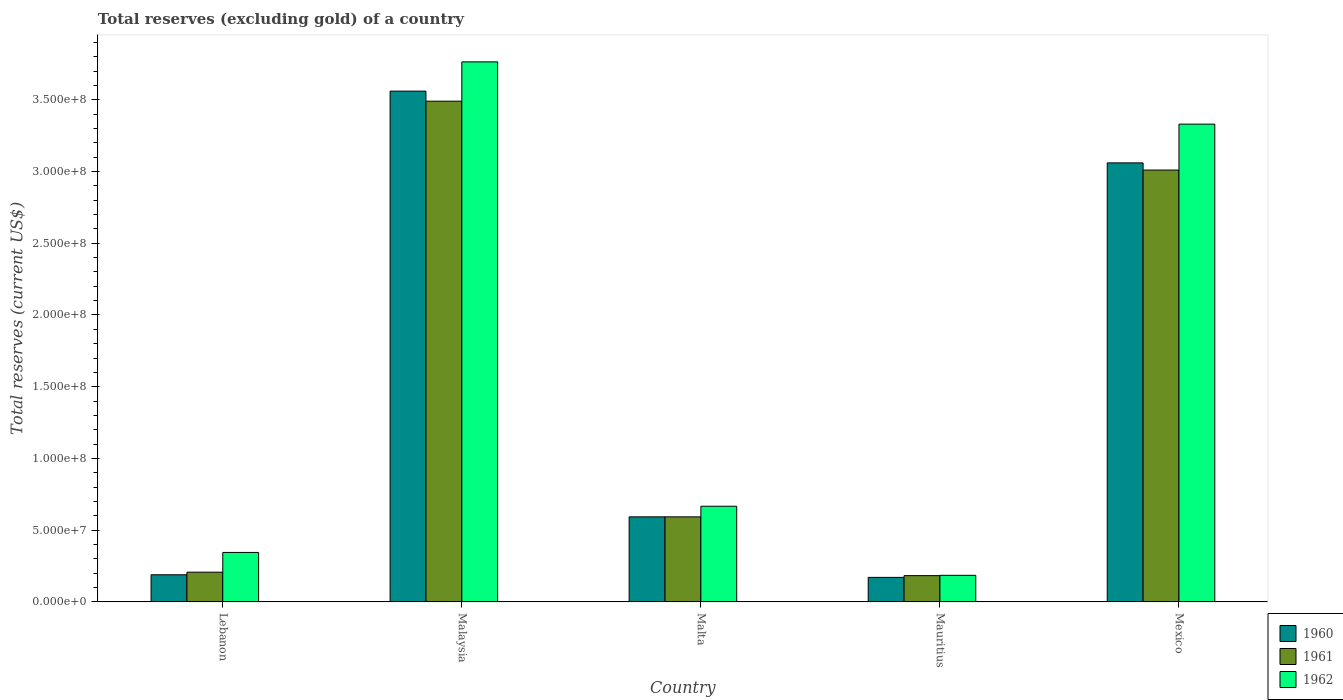Are the number of bars per tick equal to the number of legend labels?
Ensure brevity in your answer.  Yes. How many bars are there on the 1st tick from the left?
Ensure brevity in your answer.  3. How many bars are there on the 5th tick from the right?
Your response must be concise. 3. What is the label of the 3rd group of bars from the left?
Your response must be concise. Malta. In how many cases, is the number of bars for a given country not equal to the number of legend labels?
Provide a succinct answer. 0. What is the total reserves (excluding gold) in 1961 in Malta?
Your answer should be very brief. 5.93e+07. Across all countries, what is the maximum total reserves (excluding gold) in 1960?
Offer a terse response. 3.56e+08. Across all countries, what is the minimum total reserves (excluding gold) in 1960?
Offer a terse response. 1.71e+07. In which country was the total reserves (excluding gold) in 1962 maximum?
Your response must be concise. Malaysia. In which country was the total reserves (excluding gold) in 1960 minimum?
Provide a short and direct response. Mauritius. What is the total total reserves (excluding gold) in 1961 in the graph?
Provide a short and direct response. 7.48e+08. What is the difference between the total reserves (excluding gold) in 1960 in Malaysia and that in Malta?
Your response must be concise. 2.97e+08. What is the difference between the total reserves (excluding gold) in 1960 in Malta and the total reserves (excluding gold) in 1962 in Lebanon?
Your response must be concise. 2.48e+07. What is the average total reserves (excluding gold) in 1960 per country?
Keep it short and to the point. 1.51e+08. What is the difference between the total reserves (excluding gold) of/in 1960 and total reserves (excluding gold) of/in 1962 in Malta?
Offer a terse response. -7.40e+06. What is the ratio of the total reserves (excluding gold) in 1962 in Lebanon to that in Malaysia?
Offer a very short reply. 0.09. Is the total reserves (excluding gold) in 1962 in Malta less than that in Mauritius?
Provide a succinct answer. No. What is the difference between the highest and the second highest total reserves (excluding gold) in 1960?
Provide a short and direct response. 2.97e+08. What is the difference between the highest and the lowest total reserves (excluding gold) in 1962?
Ensure brevity in your answer.  3.58e+08. In how many countries, is the total reserves (excluding gold) in 1962 greater than the average total reserves (excluding gold) in 1962 taken over all countries?
Give a very brief answer. 2. What does the 2nd bar from the right in Malta represents?
Offer a terse response. 1961. Are all the bars in the graph horizontal?
Your answer should be very brief. No. Are the values on the major ticks of Y-axis written in scientific E-notation?
Your answer should be very brief. Yes. Does the graph contain any zero values?
Give a very brief answer. No. Does the graph contain grids?
Ensure brevity in your answer.  No. Where does the legend appear in the graph?
Provide a succinct answer. Bottom right. What is the title of the graph?
Provide a succinct answer. Total reserves (excluding gold) of a country. What is the label or title of the X-axis?
Provide a short and direct response. Country. What is the label or title of the Y-axis?
Offer a very short reply. Total reserves (current US$). What is the Total reserves (current US$) of 1960 in Lebanon?
Keep it short and to the point. 1.89e+07. What is the Total reserves (current US$) of 1961 in Lebanon?
Offer a terse response. 2.07e+07. What is the Total reserves (current US$) in 1962 in Lebanon?
Ensure brevity in your answer.  3.45e+07. What is the Total reserves (current US$) in 1960 in Malaysia?
Provide a succinct answer. 3.56e+08. What is the Total reserves (current US$) of 1961 in Malaysia?
Offer a terse response. 3.49e+08. What is the Total reserves (current US$) in 1962 in Malaysia?
Your answer should be compact. 3.76e+08. What is the Total reserves (current US$) of 1960 in Malta?
Offer a very short reply. 5.93e+07. What is the Total reserves (current US$) in 1961 in Malta?
Provide a short and direct response. 5.93e+07. What is the Total reserves (current US$) of 1962 in Malta?
Provide a short and direct response. 6.67e+07. What is the Total reserves (current US$) in 1960 in Mauritius?
Provide a short and direct response. 1.71e+07. What is the Total reserves (current US$) in 1961 in Mauritius?
Your answer should be compact. 1.83e+07. What is the Total reserves (current US$) of 1962 in Mauritius?
Provide a succinct answer. 1.86e+07. What is the Total reserves (current US$) in 1960 in Mexico?
Keep it short and to the point. 3.06e+08. What is the Total reserves (current US$) in 1961 in Mexico?
Offer a very short reply. 3.01e+08. What is the Total reserves (current US$) of 1962 in Mexico?
Offer a very short reply. 3.33e+08. Across all countries, what is the maximum Total reserves (current US$) of 1960?
Provide a succinct answer. 3.56e+08. Across all countries, what is the maximum Total reserves (current US$) of 1961?
Provide a succinct answer. 3.49e+08. Across all countries, what is the maximum Total reserves (current US$) of 1962?
Make the answer very short. 3.76e+08. Across all countries, what is the minimum Total reserves (current US$) of 1960?
Provide a succinct answer. 1.71e+07. Across all countries, what is the minimum Total reserves (current US$) of 1961?
Give a very brief answer. 1.83e+07. Across all countries, what is the minimum Total reserves (current US$) of 1962?
Offer a terse response. 1.86e+07. What is the total Total reserves (current US$) of 1960 in the graph?
Offer a terse response. 7.57e+08. What is the total Total reserves (current US$) in 1961 in the graph?
Your response must be concise. 7.48e+08. What is the total Total reserves (current US$) of 1962 in the graph?
Your answer should be compact. 8.29e+08. What is the difference between the Total reserves (current US$) in 1960 in Lebanon and that in Malaysia?
Ensure brevity in your answer.  -3.37e+08. What is the difference between the Total reserves (current US$) in 1961 in Lebanon and that in Malaysia?
Give a very brief answer. -3.28e+08. What is the difference between the Total reserves (current US$) of 1962 in Lebanon and that in Malaysia?
Your answer should be compact. -3.42e+08. What is the difference between the Total reserves (current US$) of 1960 in Lebanon and that in Malta?
Offer a terse response. -4.04e+07. What is the difference between the Total reserves (current US$) of 1961 in Lebanon and that in Malta?
Your answer should be very brief. -3.86e+07. What is the difference between the Total reserves (current US$) of 1962 in Lebanon and that in Malta?
Your answer should be compact. -3.22e+07. What is the difference between the Total reserves (current US$) of 1960 in Lebanon and that in Mauritius?
Provide a succinct answer. 1.82e+06. What is the difference between the Total reserves (current US$) of 1961 in Lebanon and that in Mauritius?
Keep it short and to the point. 2.40e+06. What is the difference between the Total reserves (current US$) in 1962 in Lebanon and that in Mauritius?
Provide a succinct answer. 1.60e+07. What is the difference between the Total reserves (current US$) in 1960 in Lebanon and that in Mexico?
Make the answer very short. -2.87e+08. What is the difference between the Total reserves (current US$) in 1961 in Lebanon and that in Mexico?
Your answer should be very brief. -2.80e+08. What is the difference between the Total reserves (current US$) in 1962 in Lebanon and that in Mexico?
Give a very brief answer. -2.98e+08. What is the difference between the Total reserves (current US$) of 1960 in Malaysia and that in Malta?
Your answer should be very brief. 2.97e+08. What is the difference between the Total reserves (current US$) of 1961 in Malaysia and that in Malta?
Your answer should be compact. 2.90e+08. What is the difference between the Total reserves (current US$) of 1962 in Malaysia and that in Malta?
Keep it short and to the point. 3.10e+08. What is the difference between the Total reserves (current US$) in 1960 in Malaysia and that in Mauritius?
Offer a very short reply. 3.39e+08. What is the difference between the Total reserves (current US$) of 1961 in Malaysia and that in Mauritius?
Keep it short and to the point. 3.31e+08. What is the difference between the Total reserves (current US$) in 1962 in Malaysia and that in Mauritius?
Your answer should be very brief. 3.58e+08. What is the difference between the Total reserves (current US$) of 1960 in Malaysia and that in Mexico?
Make the answer very short. 5.00e+07. What is the difference between the Total reserves (current US$) of 1961 in Malaysia and that in Mexico?
Ensure brevity in your answer.  4.80e+07. What is the difference between the Total reserves (current US$) of 1962 in Malaysia and that in Mexico?
Provide a succinct answer. 4.34e+07. What is the difference between the Total reserves (current US$) of 1960 in Malta and that in Mauritius?
Your answer should be very brief. 4.22e+07. What is the difference between the Total reserves (current US$) in 1961 in Malta and that in Mauritius?
Your answer should be compact. 4.10e+07. What is the difference between the Total reserves (current US$) in 1962 in Malta and that in Mauritius?
Give a very brief answer. 4.82e+07. What is the difference between the Total reserves (current US$) of 1960 in Malta and that in Mexico?
Keep it short and to the point. -2.47e+08. What is the difference between the Total reserves (current US$) in 1961 in Malta and that in Mexico?
Give a very brief answer. -2.42e+08. What is the difference between the Total reserves (current US$) of 1962 in Malta and that in Mexico?
Your answer should be very brief. -2.66e+08. What is the difference between the Total reserves (current US$) in 1960 in Mauritius and that in Mexico?
Make the answer very short. -2.89e+08. What is the difference between the Total reserves (current US$) in 1961 in Mauritius and that in Mexico?
Offer a terse response. -2.83e+08. What is the difference between the Total reserves (current US$) of 1962 in Mauritius and that in Mexico?
Keep it short and to the point. -3.14e+08. What is the difference between the Total reserves (current US$) of 1960 in Lebanon and the Total reserves (current US$) of 1961 in Malaysia?
Provide a succinct answer. -3.30e+08. What is the difference between the Total reserves (current US$) of 1960 in Lebanon and the Total reserves (current US$) of 1962 in Malaysia?
Provide a succinct answer. -3.57e+08. What is the difference between the Total reserves (current US$) of 1961 in Lebanon and the Total reserves (current US$) of 1962 in Malaysia?
Provide a succinct answer. -3.56e+08. What is the difference between the Total reserves (current US$) of 1960 in Lebanon and the Total reserves (current US$) of 1961 in Malta?
Your response must be concise. -4.04e+07. What is the difference between the Total reserves (current US$) in 1960 in Lebanon and the Total reserves (current US$) in 1962 in Malta?
Provide a short and direct response. -4.78e+07. What is the difference between the Total reserves (current US$) of 1961 in Lebanon and the Total reserves (current US$) of 1962 in Malta?
Your answer should be compact. -4.60e+07. What is the difference between the Total reserves (current US$) of 1960 in Lebanon and the Total reserves (current US$) of 1961 in Mauritius?
Ensure brevity in your answer.  6.00e+05. What is the difference between the Total reserves (current US$) of 1960 in Lebanon and the Total reserves (current US$) of 1962 in Mauritius?
Keep it short and to the point. 3.90e+05. What is the difference between the Total reserves (current US$) in 1961 in Lebanon and the Total reserves (current US$) in 1962 in Mauritius?
Offer a very short reply. 2.19e+06. What is the difference between the Total reserves (current US$) in 1960 in Lebanon and the Total reserves (current US$) in 1961 in Mexico?
Your answer should be very brief. -2.82e+08. What is the difference between the Total reserves (current US$) in 1960 in Lebanon and the Total reserves (current US$) in 1962 in Mexico?
Your answer should be compact. -3.14e+08. What is the difference between the Total reserves (current US$) of 1961 in Lebanon and the Total reserves (current US$) of 1962 in Mexico?
Your response must be concise. -3.12e+08. What is the difference between the Total reserves (current US$) in 1960 in Malaysia and the Total reserves (current US$) in 1961 in Malta?
Give a very brief answer. 2.97e+08. What is the difference between the Total reserves (current US$) of 1960 in Malaysia and the Total reserves (current US$) of 1962 in Malta?
Your answer should be compact. 2.89e+08. What is the difference between the Total reserves (current US$) in 1961 in Malaysia and the Total reserves (current US$) in 1962 in Malta?
Provide a short and direct response. 2.82e+08. What is the difference between the Total reserves (current US$) in 1960 in Malaysia and the Total reserves (current US$) in 1961 in Mauritius?
Provide a succinct answer. 3.38e+08. What is the difference between the Total reserves (current US$) in 1960 in Malaysia and the Total reserves (current US$) in 1962 in Mauritius?
Provide a succinct answer. 3.37e+08. What is the difference between the Total reserves (current US$) of 1961 in Malaysia and the Total reserves (current US$) of 1962 in Mauritius?
Offer a very short reply. 3.30e+08. What is the difference between the Total reserves (current US$) in 1960 in Malaysia and the Total reserves (current US$) in 1961 in Mexico?
Provide a succinct answer. 5.50e+07. What is the difference between the Total reserves (current US$) in 1960 in Malaysia and the Total reserves (current US$) in 1962 in Mexico?
Provide a short and direct response. 2.30e+07. What is the difference between the Total reserves (current US$) of 1961 in Malaysia and the Total reserves (current US$) of 1962 in Mexico?
Ensure brevity in your answer.  1.60e+07. What is the difference between the Total reserves (current US$) of 1960 in Malta and the Total reserves (current US$) of 1961 in Mauritius?
Your answer should be very brief. 4.10e+07. What is the difference between the Total reserves (current US$) of 1960 in Malta and the Total reserves (current US$) of 1962 in Mauritius?
Offer a terse response. 4.08e+07. What is the difference between the Total reserves (current US$) of 1961 in Malta and the Total reserves (current US$) of 1962 in Mauritius?
Give a very brief answer. 4.08e+07. What is the difference between the Total reserves (current US$) of 1960 in Malta and the Total reserves (current US$) of 1961 in Mexico?
Give a very brief answer. -2.42e+08. What is the difference between the Total reserves (current US$) in 1960 in Malta and the Total reserves (current US$) in 1962 in Mexico?
Your answer should be compact. -2.74e+08. What is the difference between the Total reserves (current US$) of 1961 in Malta and the Total reserves (current US$) of 1962 in Mexico?
Your response must be concise. -2.74e+08. What is the difference between the Total reserves (current US$) of 1960 in Mauritius and the Total reserves (current US$) of 1961 in Mexico?
Offer a terse response. -2.84e+08. What is the difference between the Total reserves (current US$) in 1960 in Mauritius and the Total reserves (current US$) in 1962 in Mexico?
Keep it short and to the point. -3.16e+08. What is the difference between the Total reserves (current US$) in 1961 in Mauritius and the Total reserves (current US$) in 1962 in Mexico?
Ensure brevity in your answer.  -3.15e+08. What is the average Total reserves (current US$) in 1960 per country?
Your answer should be compact. 1.51e+08. What is the average Total reserves (current US$) in 1961 per country?
Give a very brief answer. 1.50e+08. What is the average Total reserves (current US$) of 1962 per country?
Your response must be concise. 1.66e+08. What is the difference between the Total reserves (current US$) of 1960 and Total reserves (current US$) of 1961 in Lebanon?
Give a very brief answer. -1.80e+06. What is the difference between the Total reserves (current US$) in 1960 and Total reserves (current US$) in 1962 in Lebanon?
Your answer should be very brief. -1.56e+07. What is the difference between the Total reserves (current US$) of 1961 and Total reserves (current US$) of 1962 in Lebanon?
Provide a short and direct response. -1.38e+07. What is the difference between the Total reserves (current US$) of 1960 and Total reserves (current US$) of 1962 in Malaysia?
Your response must be concise. -2.04e+07. What is the difference between the Total reserves (current US$) of 1961 and Total reserves (current US$) of 1962 in Malaysia?
Keep it short and to the point. -2.74e+07. What is the difference between the Total reserves (current US$) of 1960 and Total reserves (current US$) of 1961 in Malta?
Keep it short and to the point. 0. What is the difference between the Total reserves (current US$) in 1960 and Total reserves (current US$) in 1962 in Malta?
Make the answer very short. -7.40e+06. What is the difference between the Total reserves (current US$) in 1961 and Total reserves (current US$) in 1962 in Malta?
Ensure brevity in your answer.  -7.40e+06. What is the difference between the Total reserves (current US$) in 1960 and Total reserves (current US$) in 1961 in Mauritius?
Offer a terse response. -1.22e+06. What is the difference between the Total reserves (current US$) of 1960 and Total reserves (current US$) of 1962 in Mauritius?
Provide a succinct answer. -1.43e+06. What is the difference between the Total reserves (current US$) of 1961 and Total reserves (current US$) of 1962 in Mauritius?
Your answer should be very brief. -2.10e+05. What is the difference between the Total reserves (current US$) of 1960 and Total reserves (current US$) of 1961 in Mexico?
Provide a short and direct response. 5.00e+06. What is the difference between the Total reserves (current US$) in 1960 and Total reserves (current US$) in 1962 in Mexico?
Provide a short and direct response. -2.70e+07. What is the difference between the Total reserves (current US$) of 1961 and Total reserves (current US$) of 1962 in Mexico?
Provide a short and direct response. -3.20e+07. What is the ratio of the Total reserves (current US$) in 1960 in Lebanon to that in Malaysia?
Your answer should be compact. 0.05. What is the ratio of the Total reserves (current US$) in 1961 in Lebanon to that in Malaysia?
Provide a short and direct response. 0.06. What is the ratio of the Total reserves (current US$) in 1962 in Lebanon to that in Malaysia?
Your response must be concise. 0.09. What is the ratio of the Total reserves (current US$) in 1960 in Lebanon to that in Malta?
Offer a terse response. 0.32. What is the ratio of the Total reserves (current US$) of 1961 in Lebanon to that in Malta?
Provide a succinct answer. 0.35. What is the ratio of the Total reserves (current US$) in 1962 in Lebanon to that in Malta?
Make the answer very short. 0.52. What is the ratio of the Total reserves (current US$) of 1960 in Lebanon to that in Mauritius?
Provide a succinct answer. 1.11. What is the ratio of the Total reserves (current US$) of 1961 in Lebanon to that in Mauritius?
Your response must be concise. 1.13. What is the ratio of the Total reserves (current US$) in 1962 in Lebanon to that in Mauritius?
Give a very brief answer. 1.86. What is the ratio of the Total reserves (current US$) of 1960 in Lebanon to that in Mexico?
Keep it short and to the point. 0.06. What is the ratio of the Total reserves (current US$) of 1961 in Lebanon to that in Mexico?
Your answer should be very brief. 0.07. What is the ratio of the Total reserves (current US$) in 1962 in Lebanon to that in Mexico?
Provide a short and direct response. 0.1. What is the ratio of the Total reserves (current US$) in 1960 in Malaysia to that in Malta?
Give a very brief answer. 6. What is the ratio of the Total reserves (current US$) of 1961 in Malaysia to that in Malta?
Keep it short and to the point. 5.89. What is the ratio of the Total reserves (current US$) of 1962 in Malaysia to that in Malta?
Keep it short and to the point. 5.64. What is the ratio of the Total reserves (current US$) in 1960 in Malaysia to that in Mauritius?
Make the answer very short. 20.79. What is the ratio of the Total reserves (current US$) in 1961 in Malaysia to that in Mauritius?
Your answer should be compact. 19.03. What is the ratio of the Total reserves (current US$) of 1962 in Malaysia to that in Mauritius?
Give a very brief answer. 20.29. What is the ratio of the Total reserves (current US$) in 1960 in Malaysia to that in Mexico?
Ensure brevity in your answer.  1.16. What is the ratio of the Total reserves (current US$) in 1961 in Malaysia to that in Mexico?
Offer a terse response. 1.16. What is the ratio of the Total reserves (current US$) in 1962 in Malaysia to that in Mexico?
Make the answer very short. 1.13. What is the ratio of the Total reserves (current US$) of 1960 in Malta to that in Mauritius?
Keep it short and to the point. 3.46. What is the ratio of the Total reserves (current US$) in 1961 in Malta to that in Mauritius?
Your response must be concise. 3.23. What is the ratio of the Total reserves (current US$) in 1962 in Malta to that in Mauritius?
Keep it short and to the point. 3.6. What is the ratio of the Total reserves (current US$) in 1960 in Malta to that in Mexico?
Make the answer very short. 0.19. What is the ratio of the Total reserves (current US$) in 1961 in Malta to that in Mexico?
Offer a terse response. 0.2. What is the ratio of the Total reserves (current US$) of 1962 in Malta to that in Mexico?
Ensure brevity in your answer.  0.2. What is the ratio of the Total reserves (current US$) in 1960 in Mauritius to that in Mexico?
Your answer should be compact. 0.06. What is the ratio of the Total reserves (current US$) in 1961 in Mauritius to that in Mexico?
Your response must be concise. 0.06. What is the ratio of the Total reserves (current US$) in 1962 in Mauritius to that in Mexico?
Your response must be concise. 0.06. What is the difference between the highest and the second highest Total reserves (current US$) of 1960?
Ensure brevity in your answer.  5.00e+07. What is the difference between the highest and the second highest Total reserves (current US$) in 1961?
Provide a short and direct response. 4.80e+07. What is the difference between the highest and the second highest Total reserves (current US$) in 1962?
Offer a very short reply. 4.34e+07. What is the difference between the highest and the lowest Total reserves (current US$) of 1960?
Offer a terse response. 3.39e+08. What is the difference between the highest and the lowest Total reserves (current US$) in 1961?
Make the answer very short. 3.31e+08. What is the difference between the highest and the lowest Total reserves (current US$) of 1962?
Provide a short and direct response. 3.58e+08. 